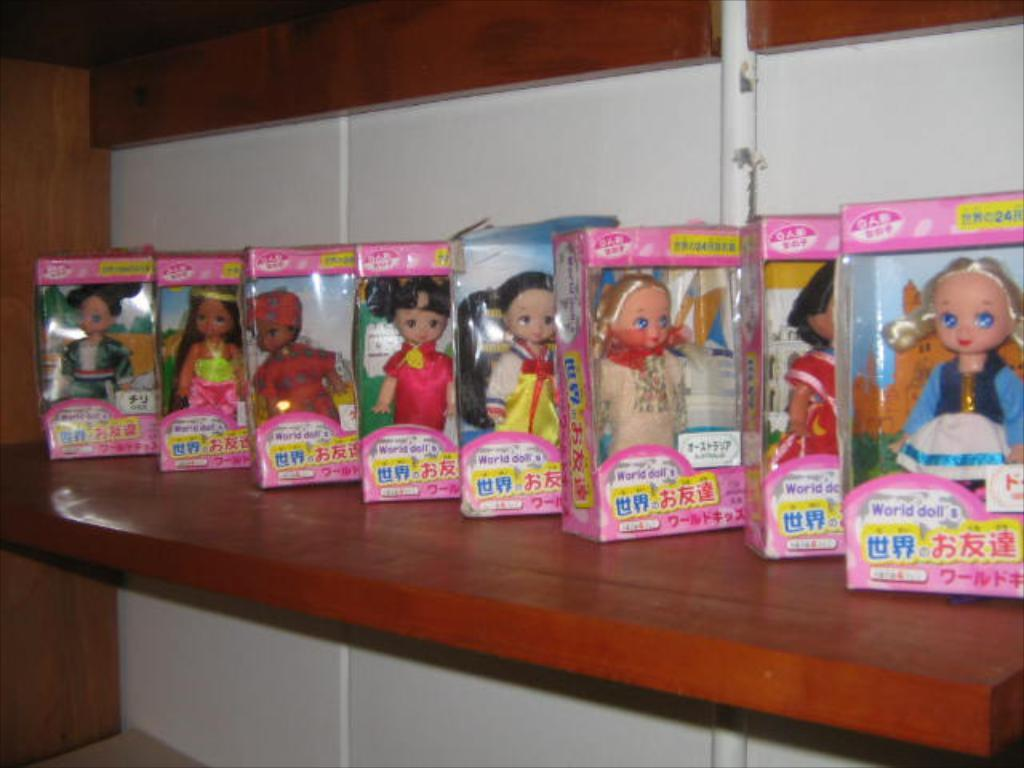What types of dolls can be seen in the image? There are different kinds of dolls in the image. How are the dolls stored or displayed in the image? The dolls are in boxes in the image. What is the surface on which the boxes are placed? The boxes are on a wooden object in the image. What can be seen behind the boxes? There is a wall and a pipe visible behind the boxes in the image. What type of game is being played in the image? There is no game being played in the image; it features dolls in boxes on a wooden object. What shape is the protest taking in the image? There is no protest present in the image; it features dolls in boxes on a wooden object. 